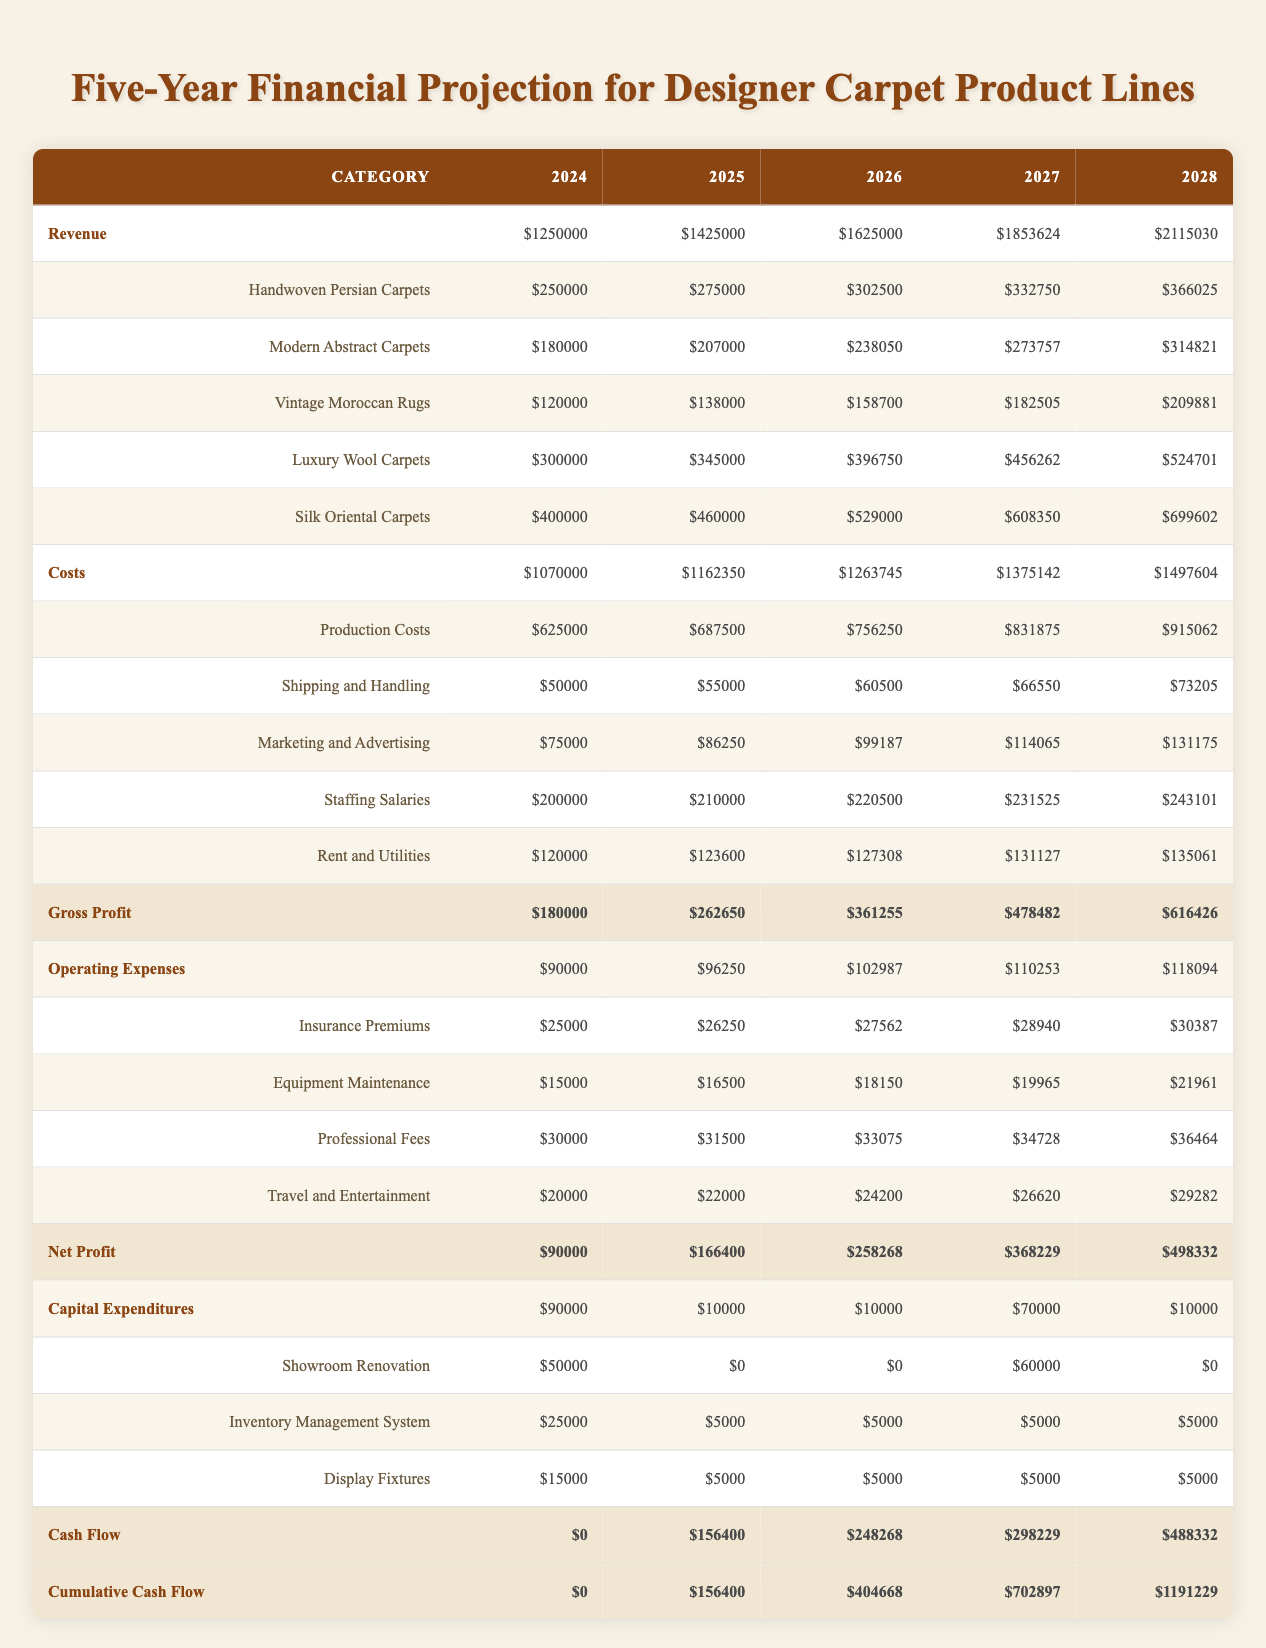What is the projected revenue for Silk Oriental Carpets in 2026? The projected revenue for Silk Oriental Carpets in 2026 can be found in the revenue section of the table under the respective row. Looking at the data, it shows $529,000 for the year 2026.
Answer: 529000 What are the total estimated costs for production in 2025? The total estimated costs for production in 2025 is found in the costs section under the Production Costs row. It shows $687,500 for that year.
Answer: 687500 Is the net profit expected to increase every year? The net profit for each year in the table shows a consistent upward trend: $90,000 in 2024, $166,400 in 2025, $258,268 in 2026, $368,229 in 2027, and $498,332 in 2028. Since all values are increasing, the statement is true.
Answer: Yes What is the total revenue from all product lines in 2024? To calculate the total revenue from all product lines in 2024, we must sum the revenues of each product: Handwoven Persian Carpets ($250,000) + Modern Abstract Carpets ($180,000) + Vintage Moroccan Rugs ($120,000) + Luxury Wool Carpets ($300,000) + Silk Oriental Carpets ($400,000). The sum is $1,250,000.
Answer: 1250000 What is the average annual growth rate of gross profit from 2024 to 2028? The gross profit for 2024 is $180,000 and for 2028, it is $616,426. The growth in gross profit can be calculated as (616426 - 180000) / 180000 = 2.4246. To find the average annual growth rate, we divide the total growth by the number of years (4) which gives approximately 0.60615 or 60.61%.
Answer: 60.61% How much did the company spend on capital expenditures in 2025? The capital expenditures for 2025 are listed in the capital expenditures section. The total amount spent in that year is $10,000.
Answer: 10000 Was the cumulative cash flow positive in 2024? The cumulative cash flow for 2024 is listed in the last row of the table and shows $0, indicating that the cumulative cash flow was not positive in that year.
Answer: No What is the difference in marketing and advertising costs between 2026 and 2027? To find the difference, we take the marketing and advertising cost for 2027 ($114,065) and subtract the cost for 2026 ($99,187): 114065 - 99187 = $14,878.
Answer: 14878 How much is allocated for insurance premiums in the last year of the projection? According to the operating expenses section of the table, the insurance premiums allocated for 2028 is $30,387.
Answer: 30387 